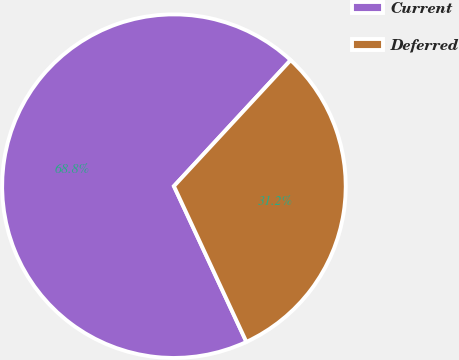Convert chart. <chart><loc_0><loc_0><loc_500><loc_500><pie_chart><fcel>Current<fcel>Deferred<nl><fcel>68.82%<fcel>31.18%<nl></chart> 